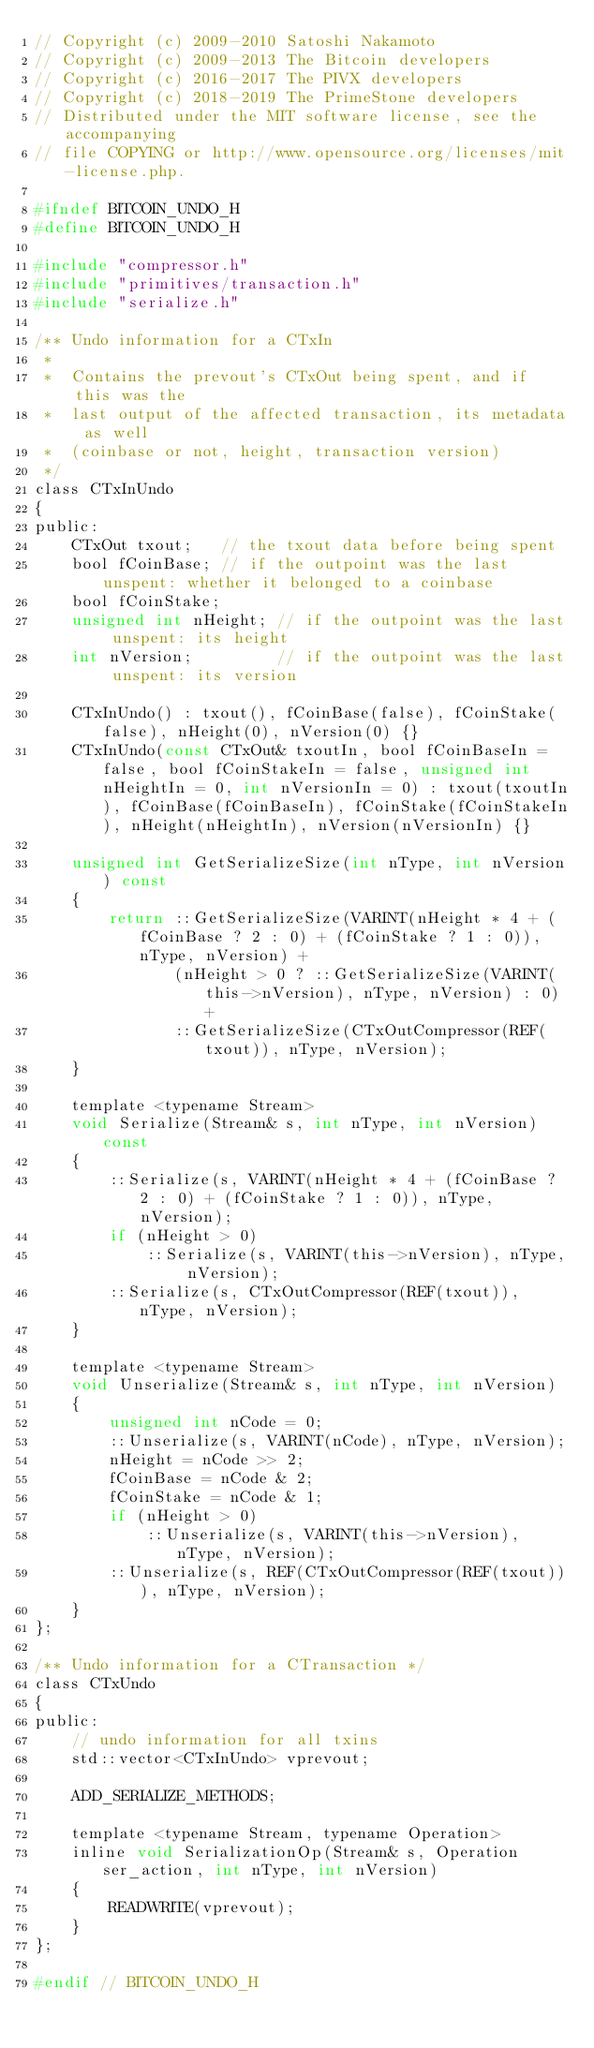Convert code to text. <code><loc_0><loc_0><loc_500><loc_500><_C_>// Copyright (c) 2009-2010 Satoshi Nakamoto
// Copyright (c) 2009-2013 The Bitcoin developers
// Copyright (c) 2016-2017 The PIVX developers
// Copyright (c) 2018-2019 The PrimeStone developers
// Distributed under the MIT software license, see the accompanying
// file COPYING or http://www.opensource.org/licenses/mit-license.php.

#ifndef BITCOIN_UNDO_H
#define BITCOIN_UNDO_H

#include "compressor.h"
#include "primitives/transaction.h"
#include "serialize.h"

/** Undo information for a CTxIn
 *
 *  Contains the prevout's CTxOut being spent, and if this was the
 *  last output of the affected transaction, its metadata as well
 *  (coinbase or not, height, transaction version)
 */
class CTxInUndo
{
public:
    CTxOut txout;   // the txout data before being spent
    bool fCoinBase; // if the outpoint was the last unspent: whether it belonged to a coinbase
    bool fCoinStake;
    unsigned int nHeight; // if the outpoint was the last unspent: its height
    int nVersion;         // if the outpoint was the last unspent: its version

    CTxInUndo() : txout(), fCoinBase(false), fCoinStake(false), nHeight(0), nVersion(0) {}
    CTxInUndo(const CTxOut& txoutIn, bool fCoinBaseIn = false, bool fCoinStakeIn = false, unsigned int nHeightIn = 0, int nVersionIn = 0) : txout(txoutIn), fCoinBase(fCoinBaseIn), fCoinStake(fCoinStakeIn), nHeight(nHeightIn), nVersion(nVersionIn) {}

    unsigned int GetSerializeSize(int nType, int nVersion) const
    {
        return ::GetSerializeSize(VARINT(nHeight * 4 + (fCoinBase ? 2 : 0) + (fCoinStake ? 1 : 0)), nType, nVersion) +
               (nHeight > 0 ? ::GetSerializeSize(VARINT(this->nVersion), nType, nVersion) : 0) +
               ::GetSerializeSize(CTxOutCompressor(REF(txout)), nType, nVersion);
    }

    template <typename Stream>
    void Serialize(Stream& s, int nType, int nVersion) const
    {
        ::Serialize(s, VARINT(nHeight * 4 + (fCoinBase ? 2 : 0) + (fCoinStake ? 1 : 0)), nType, nVersion);
        if (nHeight > 0)
            ::Serialize(s, VARINT(this->nVersion), nType, nVersion);
        ::Serialize(s, CTxOutCompressor(REF(txout)), nType, nVersion);
    }

    template <typename Stream>
    void Unserialize(Stream& s, int nType, int nVersion)
    {
        unsigned int nCode = 0;
        ::Unserialize(s, VARINT(nCode), nType, nVersion);
        nHeight = nCode >> 2;
        fCoinBase = nCode & 2;
        fCoinStake = nCode & 1;
        if (nHeight > 0)
            ::Unserialize(s, VARINT(this->nVersion), nType, nVersion);
        ::Unserialize(s, REF(CTxOutCompressor(REF(txout))), nType, nVersion);
    }
};

/** Undo information for a CTransaction */
class CTxUndo
{
public:
    // undo information for all txins
    std::vector<CTxInUndo> vprevout;

    ADD_SERIALIZE_METHODS;

    template <typename Stream, typename Operation>
    inline void SerializationOp(Stream& s, Operation ser_action, int nType, int nVersion)
    {
        READWRITE(vprevout);
    }
};

#endif // BITCOIN_UNDO_H
</code> 